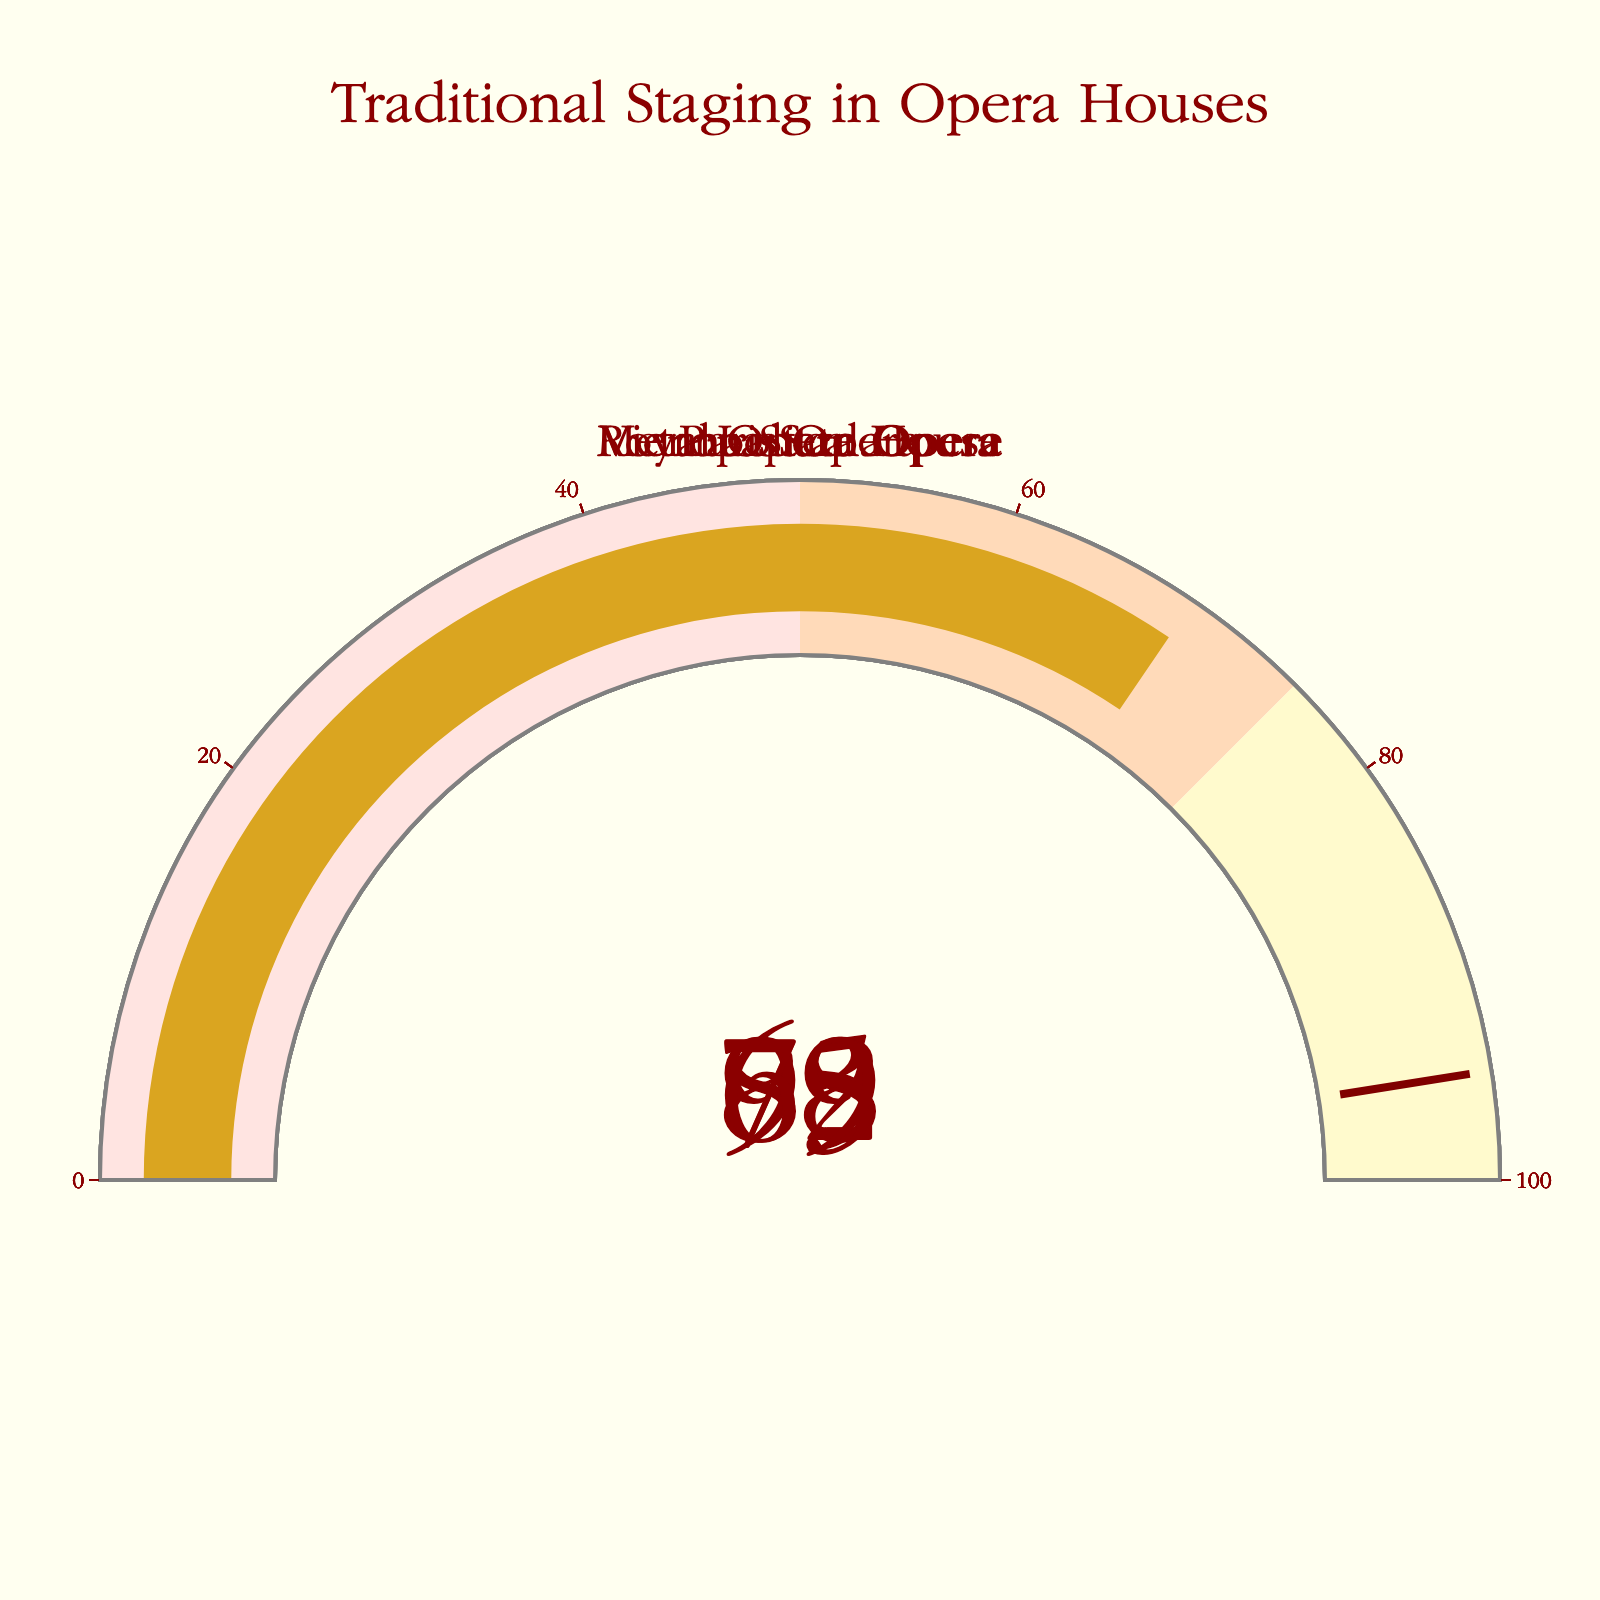what is the title of the figure? The title of the figure is displayed prominently at the top. It reads "Traditional Staging in Opera Houses".
Answer: Traditional Staging in Opera Houses what is the highest percentage of traditional staging techniques used by an opera house? Examining each gauge, La Scala shows the highest value at 92%.
Answer: 92% which opera house has the lowest percentage of traditional staging techniques? Among the gauges, the Paris Opera has the lowest percentage at 69%.
Answer: Paris Opera which opera house has a staging percentage equal to or above 80%? The gauges for Vienna State Opera and La Scala both indicate percentages above 80%, specifically 85% and 92% respectively, while the Metropolitan Opera also shows 78%, which is just below 80%.
Answer: Vienna State Opera, La Scala what is the difference in traditional staging percentages between the Royal Opera House and the Paris Opera? The Royal Opera House has a percentage of 73%, and the Paris Opera has 69%. The difference is 73 - 69 = 4%.
Answer: 4% how many opera houses have a percentage of traditional staging lower than 75%? Only the Paris Opera with 69% and Royal Opera House with 73% fall below 75%.
Answer: 2 what is the average percentage of traditional staging across all opera houses? Adding the percentages (78 + 85 + 92 + 73 + 69) gives a total of 397. Dividing by the number of opera houses (5) results in an average of 397/5 = 79.4%.
Answer: 79.4% how does the staging percentage of the Metropolitan Opera compare with the Paris Opera? The Metropolitan Opera has a percentage of 78%, which is higher than the Paris Opera's 69%.
Answer: Higher are the traditional staging percentages for the Vienna State Opera and La Scala within the same color band on the gauges? Both Vienna State Opera (85%) and La Scala (92%) are within the highest color band, which ranges from 75% to 100%, indicated by the yellow color (lemonchiffon).
Answer: Yes 